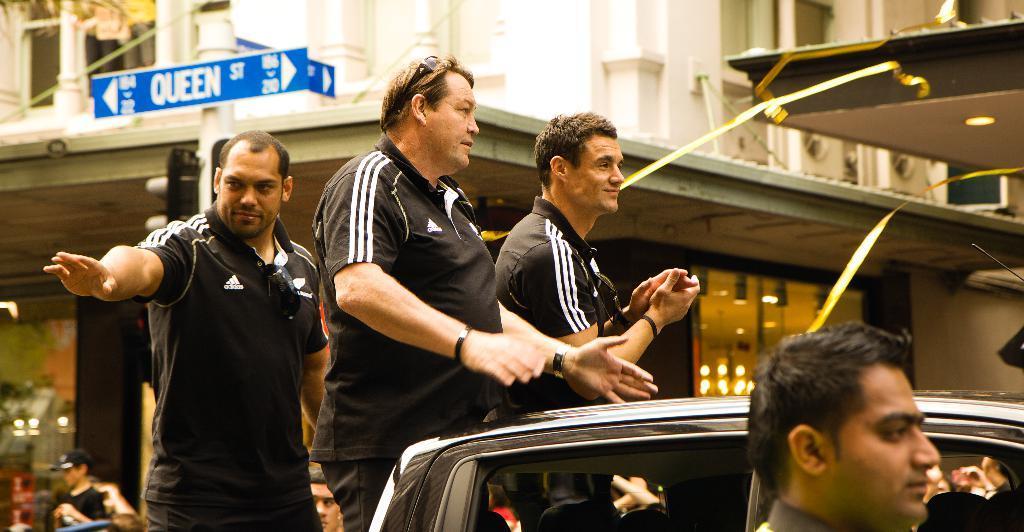How would you summarize this image in a sentence or two? In the picture I can see these people wearing black T-shirts are standing in the vehicle which is moving on the road and we can see a few more people are walking on the road. The background of the image is slightly blurred, where we can see blue color boards and traffic signals are fixed to the poles and we can see the buildings with glass doors. 